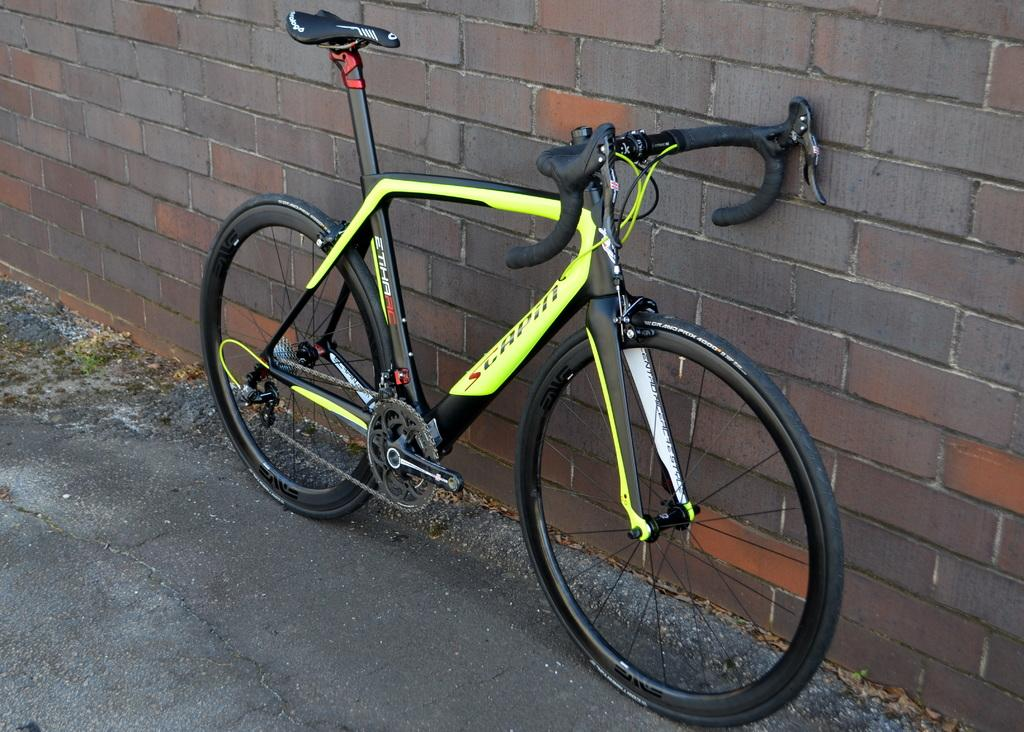What is the main subject of the image? The main subject of the image is a bicycle. What can be seen in the background of the image? There is a wall in the background of the image. What type of value can be seen on the bicycle in the image? There is no specific value visible on the bicycle in the image. Is there any snow present in the image? There is no snow present in the image. Can you see a kettle in the image? There is no kettle present in the image. 